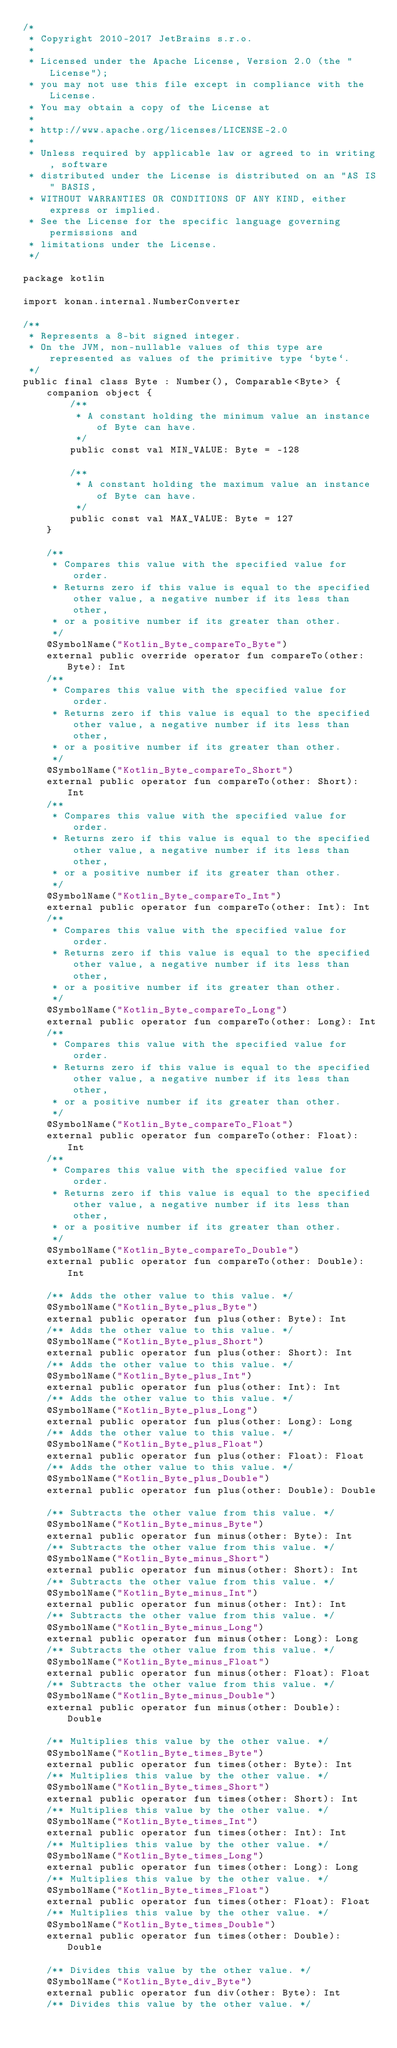<code> <loc_0><loc_0><loc_500><loc_500><_Kotlin_>/*
 * Copyright 2010-2017 JetBrains s.r.o.
 *
 * Licensed under the Apache License, Version 2.0 (the "License");
 * you may not use this file except in compliance with the License.
 * You may obtain a copy of the License at
 *
 * http://www.apache.org/licenses/LICENSE-2.0
 *
 * Unless required by applicable law or agreed to in writing, software
 * distributed under the License is distributed on an "AS IS" BASIS,
 * WITHOUT WARRANTIES OR CONDITIONS OF ANY KIND, either express or implied.
 * See the License for the specific language governing permissions and
 * limitations under the License.
 */

package kotlin

import konan.internal.NumberConverter

/**
 * Represents a 8-bit signed integer.
 * On the JVM, non-nullable values of this type are represented as values of the primitive type `byte`.
 */
public final class Byte : Number(), Comparable<Byte> {
    companion object {
        /**
         * A constant holding the minimum value an instance of Byte can have.
         */
        public const val MIN_VALUE: Byte = -128

        /**
         * A constant holding the maximum value an instance of Byte can have.
         */
        public const val MAX_VALUE: Byte = 127
    }

    /**
     * Compares this value with the specified value for order.
     * Returns zero if this value is equal to the specified other value, a negative number if its less than other,
     * or a positive number if its greater than other.
     */
    @SymbolName("Kotlin_Byte_compareTo_Byte")
    external public override operator fun compareTo(other: Byte): Int
    /**
     * Compares this value with the specified value for order.
     * Returns zero if this value is equal to the specified other value, a negative number if its less than other,
     * or a positive number if its greater than other.
     */
    @SymbolName("Kotlin_Byte_compareTo_Short")
    external public operator fun compareTo(other: Short): Int
    /**
     * Compares this value with the specified value for order.
     * Returns zero if this value is equal to the specified other value, a negative number if its less than other,
     * or a positive number if its greater than other.
     */
    @SymbolName("Kotlin_Byte_compareTo_Int")
    external public operator fun compareTo(other: Int): Int
    /**
     * Compares this value with the specified value for order.
     * Returns zero if this value is equal to the specified other value, a negative number if its less than other,
     * or a positive number if its greater than other.
     */
    @SymbolName("Kotlin_Byte_compareTo_Long")
    external public operator fun compareTo(other: Long): Int
    /**
     * Compares this value with the specified value for order.
     * Returns zero if this value is equal to the specified other value, a negative number if its less than other,
     * or a positive number if its greater than other.
     */
    @SymbolName("Kotlin_Byte_compareTo_Float")
    external public operator fun compareTo(other: Float): Int
    /**
     * Compares this value with the specified value for order.
     * Returns zero if this value is equal to the specified other value, a negative number if its less than other,
     * or a positive number if its greater than other.
     */
    @SymbolName("Kotlin_Byte_compareTo_Double")
    external public operator fun compareTo(other: Double): Int

    /** Adds the other value to this value. */
    @SymbolName("Kotlin_Byte_plus_Byte")
    external public operator fun plus(other: Byte): Int
    /** Adds the other value to this value. */
    @SymbolName("Kotlin_Byte_plus_Short")
    external public operator fun plus(other: Short): Int
    /** Adds the other value to this value. */
    @SymbolName("Kotlin_Byte_plus_Int")
    external public operator fun plus(other: Int): Int
    /** Adds the other value to this value. */
    @SymbolName("Kotlin_Byte_plus_Long")
    external public operator fun plus(other: Long): Long
    /** Adds the other value to this value. */
    @SymbolName("Kotlin_Byte_plus_Float")
    external public operator fun plus(other: Float): Float
    /** Adds the other value to this value. */
    @SymbolName("Kotlin_Byte_plus_Double")
    external public operator fun plus(other: Double): Double

    /** Subtracts the other value from this value. */
    @SymbolName("Kotlin_Byte_minus_Byte")
    external public operator fun minus(other: Byte): Int
    /** Subtracts the other value from this value. */
    @SymbolName("Kotlin_Byte_minus_Short")
    external public operator fun minus(other: Short): Int
    /** Subtracts the other value from this value. */
    @SymbolName("Kotlin_Byte_minus_Int")
    external public operator fun minus(other: Int): Int
    /** Subtracts the other value from this value. */
    @SymbolName("Kotlin_Byte_minus_Long")
    external public operator fun minus(other: Long): Long
    /** Subtracts the other value from this value. */
    @SymbolName("Kotlin_Byte_minus_Float")
    external public operator fun minus(other: Float): Float
    /** Subtracts the other value from this value. */
    @SymbolName("Kotlin_Byte_minus_Double")
    external public operator fun minus(other: Double): Double

    /** Multiplies this value by the other value. */
    @SymbolName("Kotlin_Byte_times_Byte")
    external public operator fun times(other: Byte): Int
    /** Multiplies this value by the other value. */
    @SymbolName("Kotlin_Byte_times_Short")
    external public operator fun times(other: Short): Int
    /** Multiplies this value by the other value. */
    @SymbolName("Kotlin_Byte_times_Int")
    external public operator fun times(other: Int): Int
    /** Multiplies this value by the other value. */
    @SymbolName("Kotlin_Byte_times_Long")
    external public operator fun times(other: Long): Long
    /** Multiplies this value by the other value. */
    @SymbolName("Kotlin_Byte_times_Float")
    external public operator fun times(other: Float): Float
    /** Multiplies this value by the other value. */
    @SymbolName("Kotlin_Byte_times_Double")
    external public operator fun times(other: Double): Double

    /** Divides this value by the other value. */
    @SymbolName("Kotlin_Byte_div_Byte")
    external public operator fun div(other: Byte): Int
    /** Divides this value by the other value. */</code> 